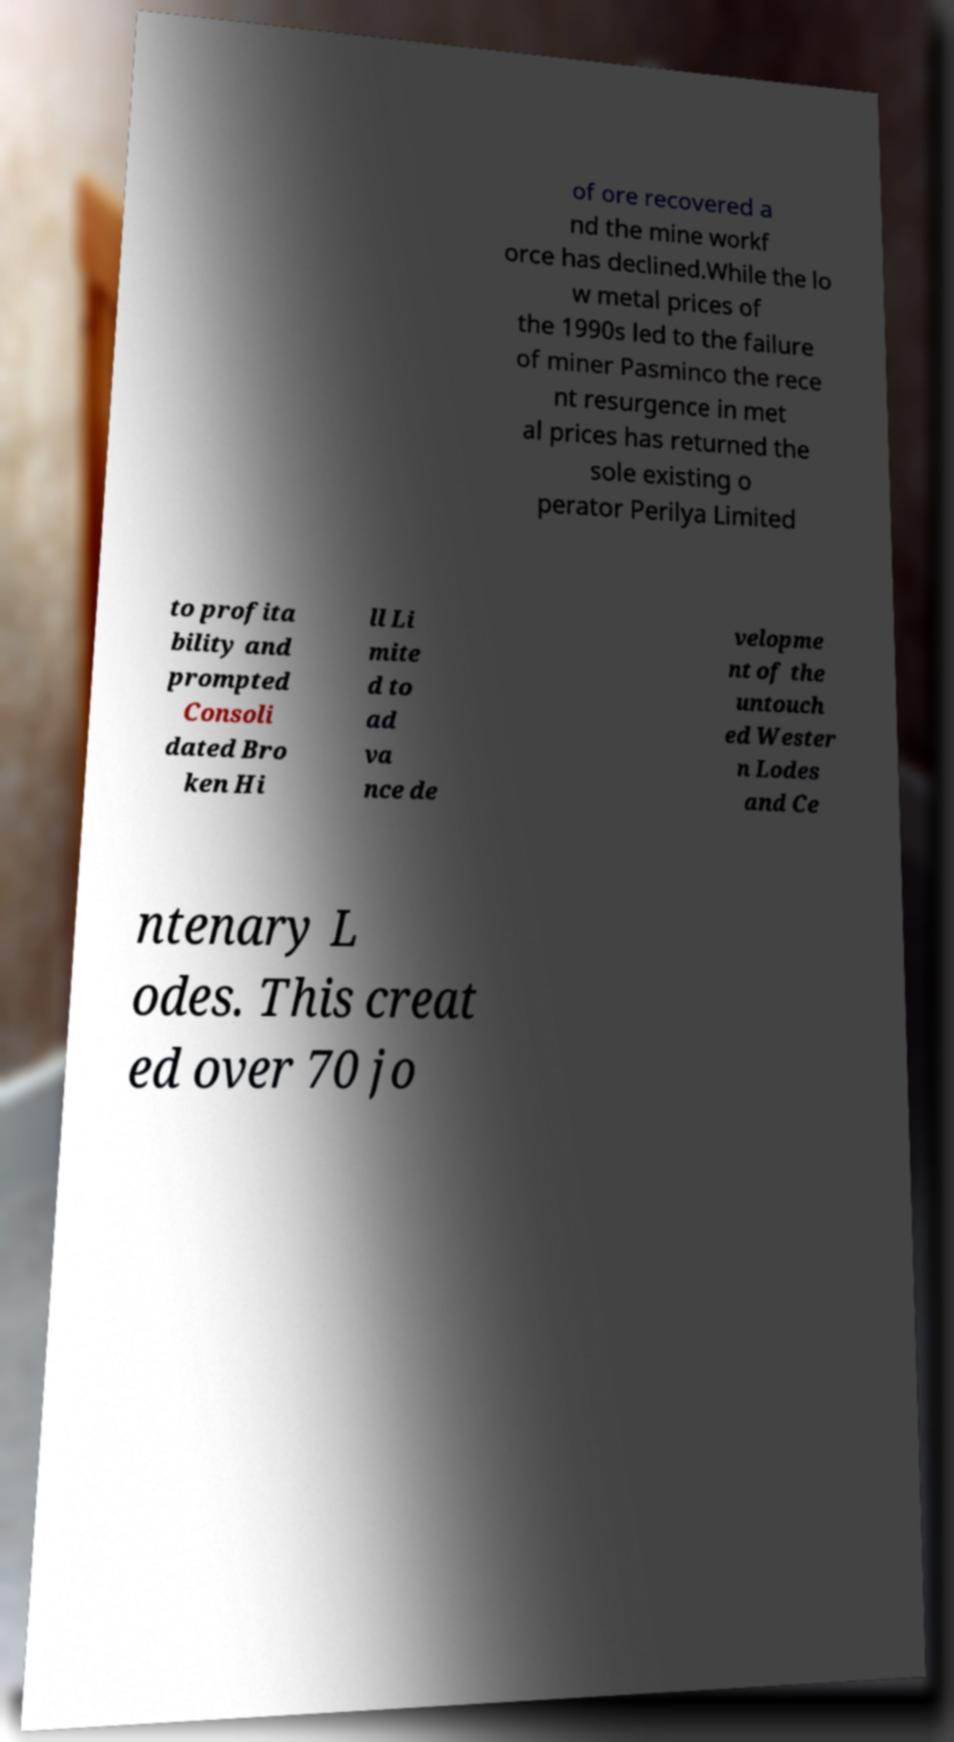I need the written content from this picture converted into text. Can you do that? of ore recovered a nd the mine workf orce has declined.While the lo w metal prices of the 1990s led to the failure of miner Pasminco the rece nt resurgence in met al prices has returned the sole existing o perator Perilya Limited to profita bility and prompted Consoli dated Bro ken Hi ll Li mite d to ad va nce de velopme nt of the untouch ed Wester n Lodes and Ce ntenary L odes. This creat ed over 70 jo 